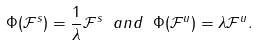Convert formula to latex. <formula><loc_0><loc_0><loc_500><loc_500>\Phi ( \mathcal { F } ^ { s } ) = \frac { 1 } { \lambda } \mathcal { F } ^ { s } \ a n d \ \Phi ( \mathcal { F } ^ { u } ) = \lambda \mathcal { F } ^ { u } .</formula> 